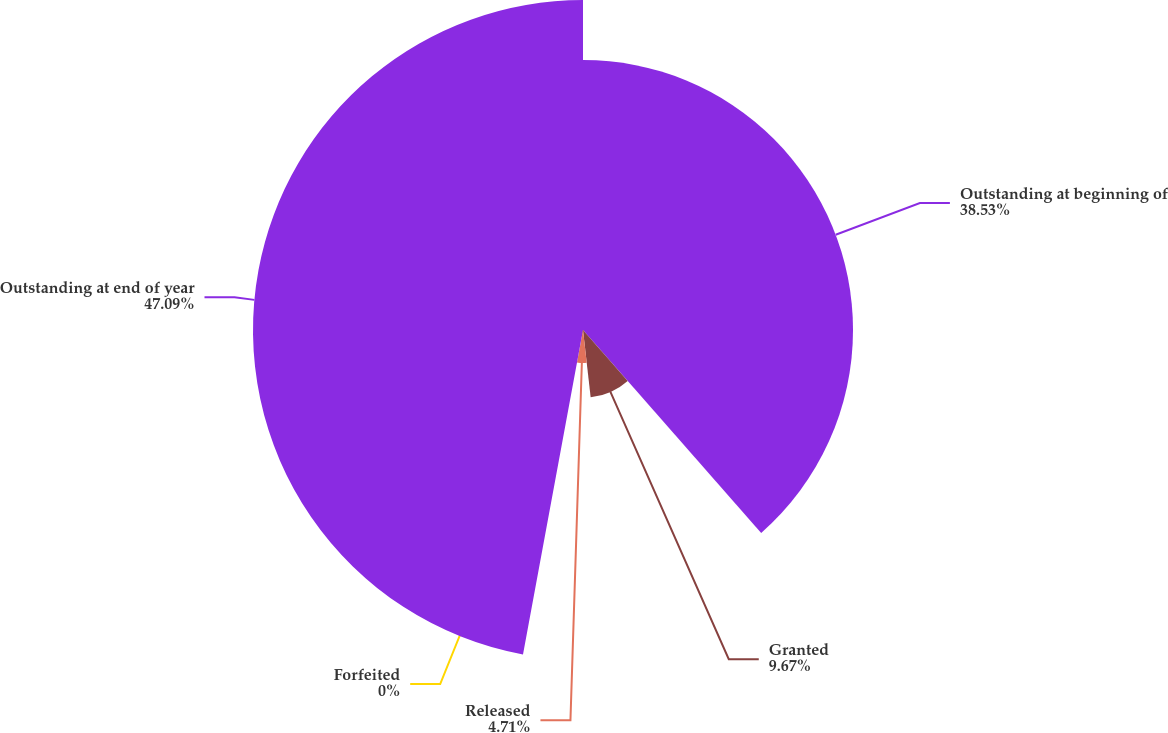Convert chart to OTSL. <chart><loc_0><loc_0><loc_500><loc_500><pie_chart><fcel>Outstanding at beginning of<fcel>Granted<fcel>Released<fcel>Forfeited<fcel>Outstanding at end of year<nl><fcel>38.53%<fcel>9.67%<fcel>4.71%<fcel>0.0%<fcel>47.09%<nl></chart> 